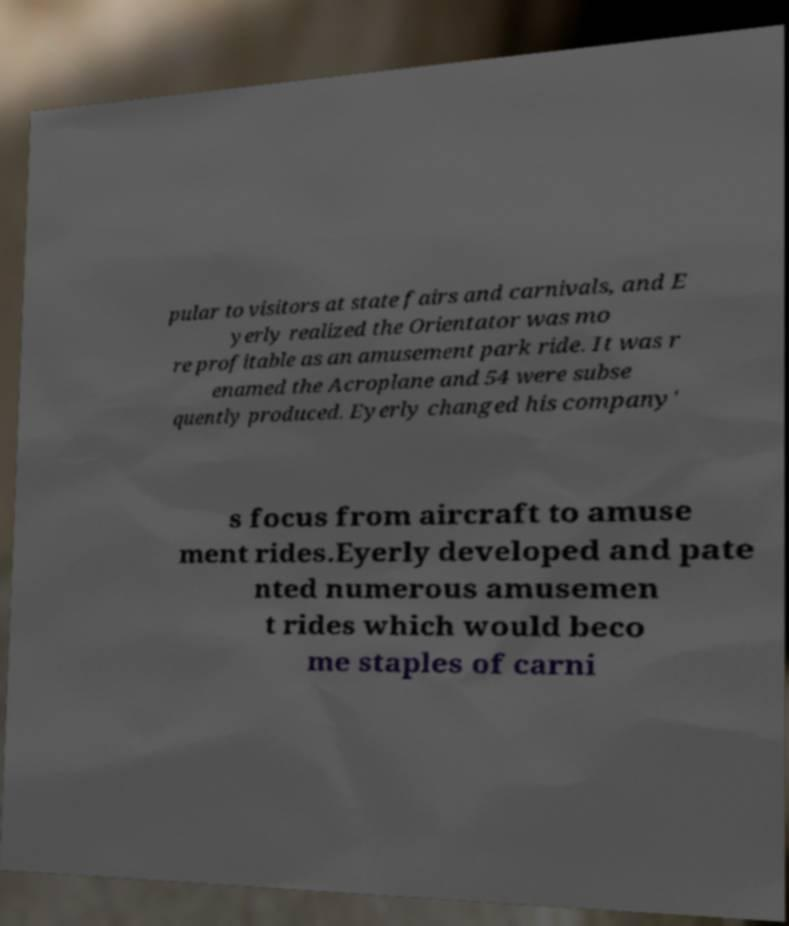For documentation purposes, I need the text within this image transcribed. Could you provide that? pular to visitors at state fairs and carnivals, and E yerly realized the Orientator was mo re profitable as an amusement park ride. It was r enamed the Acroplane and 54 were subse quently produced. Eyerly changed his company' s focus from aircraft to amuse ment rides.Eyerly developed and pate nted numerous amusemen t rides which would beco me staples of carni 